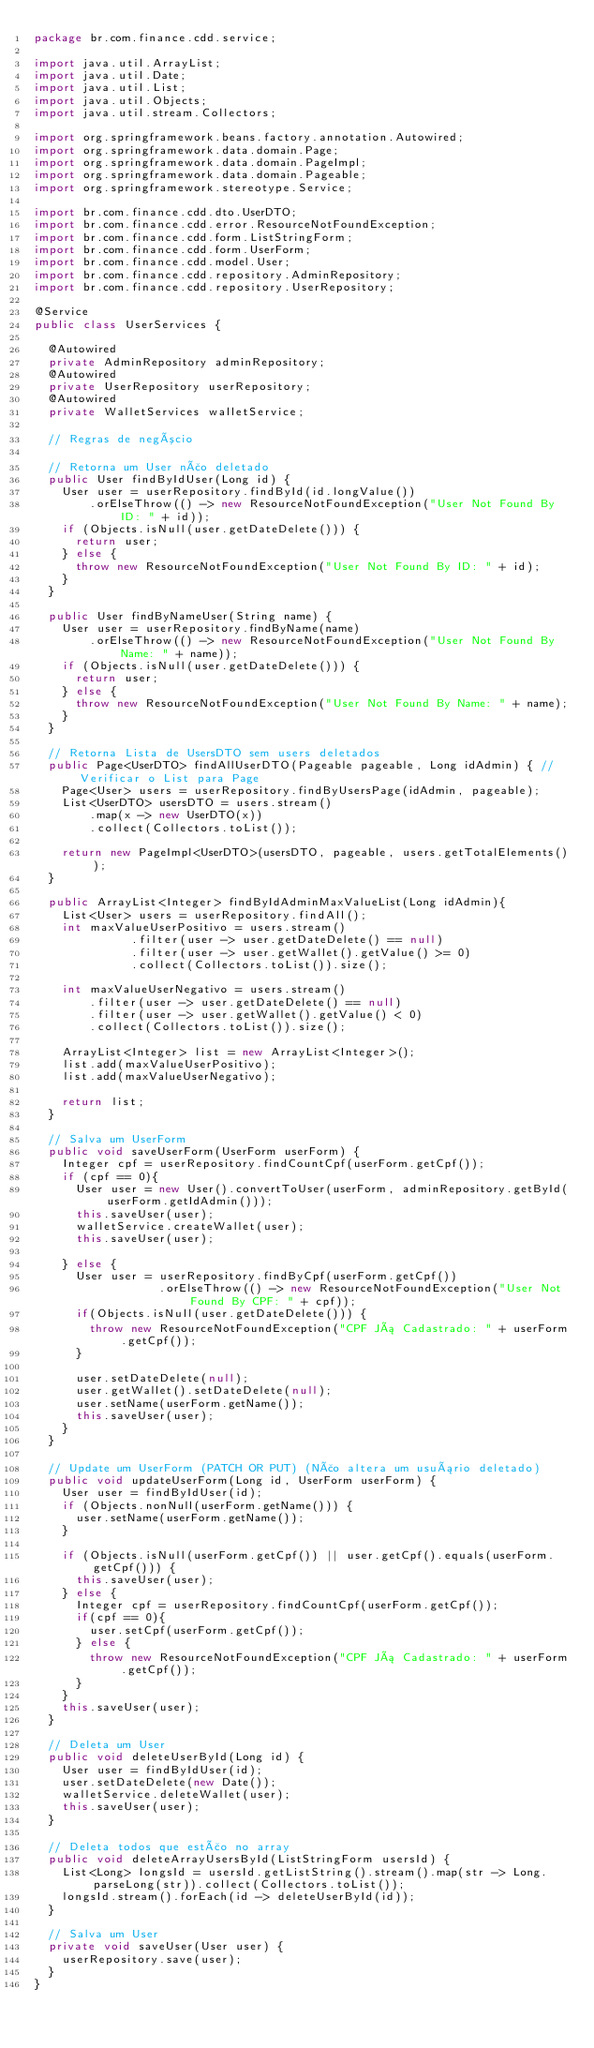<code> <loc_0><loc_0><loc_500><loc_500><_Java_>package br.com.finance.cdd.service;

import java.util.ArrayList;
import java.util.Date;
import java.util.List;
import java.util.Objects;
import java.util.stream.Collectors;

import org.springframework.beans.factory.annotation.Autowired;
import org.springframework.data.domain.Page;
import org.springframework.data.domain.PageImpl;
import org.springframework.data.domain.Pageable;
import org.springframework.stereotype.Service;

import br.com.finance.cdd.dto.UserDTO;
import br.com.finance.cdd.error.ResourceNotFoundException;
import br.com.finance.cdd.form.ListStringForm;
import br.com.finance.cdd.form.UserForm;
import br.com.finance.cdd.model.User;
import br.com.finance.cdd.repository.AdminRepository;
import br.com.finance.cdd.repository.UserRepository;

@Service
public class UserServices {

	@Autowired
	private AdminRepository adminRepository;
	@Autowired
	private UserRepository userRepository;
	@Autowired
	private WalletServices walletService;

	// Regras de negócio

	// Retorna um User não deletado
	public User findByIdUser(Long id) {
		User user = userRepository.findById(id.longValue())
				.orElseThrow(() -> new ResourceNotFoundException("User Not Found By ID: " + id));
		if (Objects.isNull(user.getDateDelete())) {
			return user;
		} else {
			throw new ResourceNotFoundException("User Not Found By ID: " + id);
		}
	}

	public User findByNameUser(String name) {
		User user = userRepository.findByName(name)
				.orElseThrow(() -> new ResourceNotFoundException("User Not Found By Name: " + name));
		if (Objects.isNull(user.getDateDelete())) {
			return user;
		} else {
			throw new ResourceNotFoundException("User Not Found By Name: " + name);
		}
	}

	// Retorna Lista de UsersDTO sem users deletados
	public Page<UserDTO> findAllUserDTO(Pageable pageable, Long idAdmin) { // Verificar o List para Page
		Page<User> users = userRepository.findByUsersPage(idAdmin, pageable);
		List<UserDTO> usersDTO = users.stream()
				.map(x -> new UserDTO(x))
				.collect(Collectors.toList());
		
		return new PageImpl<UserDTO>(usersDTO, pageable, users.getTotalElements());
	}
	
	public ArrayList<Integer> findByIdAdminMaxValueList(Long idAdmin){
		List<User> users = userRepository.findAll();
		int maxValueUserPositivo = users.stream()
							.filter(user -> user.getDateDelete() == null)
							.filter(user -> user.getWallet().getValue() >= 0)
							.collect(Collectors.toList()).size();
		
		int maxValueUserNegativo = users.stream()
				.filter(user -> user.getDateDelete() == null)
				.filter(user -> user.getWallet().getValue() < 0)
				.collect(Collectors.toList()).size();
		
		ArrayList<Integer> list = new ArrayList<Integer>();
		list.add(maxValueUserPositivo);
		list.add(maxValueUserNegativo);
		
		return list;
	}

	// Salva um UserForm
	public void saveUserForm(UserForm userForm) {
		Integer cpf = userRepository.findCountCpf(userForm.getCpf());
		if (cpf == 0){
			User user = new User().convertToUser(userForm, adminRepository.getById(userForm.getIdAdmin()));
			this.saveUser(user);
			walletService.createWallet(user);
			this.saveUser(user);
			
		} else {
			User user = userRepository.findByCpf(userForm.getCpf())
									.orElseThrow(() -> new ResourceNotFoundException("User Not Found By CPF: " + cpf));
			if(Objects.isNull(user.getDateDelete())) {
				throw new ResourceNotFoundException("CPF Já Cadastrado: " + userForm.getCpf());				
			}
			
			user.setDateDelete(null);
			user.getWallet().setDateDelete(null);
			user.setName(userForm.getName());
			this.saveUser(user);
		} 
	}

	// Update um UserForm (PATCH OR PUT) (Não altera um usuário deletado)
	public void updateUserForm(Long id, UserForm userForm) {
		User user = findByIdUser(id);
		if (Objects.nonNull(userForm.getName())) {
			user.setName(userForm.getName());
		}

		if (Objects.isNull(userForm.getCpf()) || user.getCpf().equals(userForm.getCpf())) {
			this.saveUser(user);
		} else {
			Integer cpf = userRepository.findCountCpf(userForm.getCpf());
			if(cpf == 0){
				user.setCpf(userForm.getCpf());
			} else {
				throw new ResourceNotFoundException("CPF Já Cadastrado: " + userForm.getCpf());
			}
		}
		this.saveUser(user);
	}

	// Deleta um User
	public void deleteUserById(Long id) {
		User user = findByIdUser(id);
		user.setDateDelete(new Date());
		walletService.deleteWallet(user);
		this.saveUser(user);
	}
	
	// Deleta todos que estão no array
	public void deleteArrayUsersById(ListStringForm usersId) {
		List<Long> longsId = usersId.getListString().stream().map(str -> Long.parseLong(str)).collect(Collectors.toList());
		longsId.stream().forEach(id -> deleteUserById(id));
	}

	// Salva um User
	private void saveUser(User user) {
		userRepository.save(user);
	}
}
</code> 